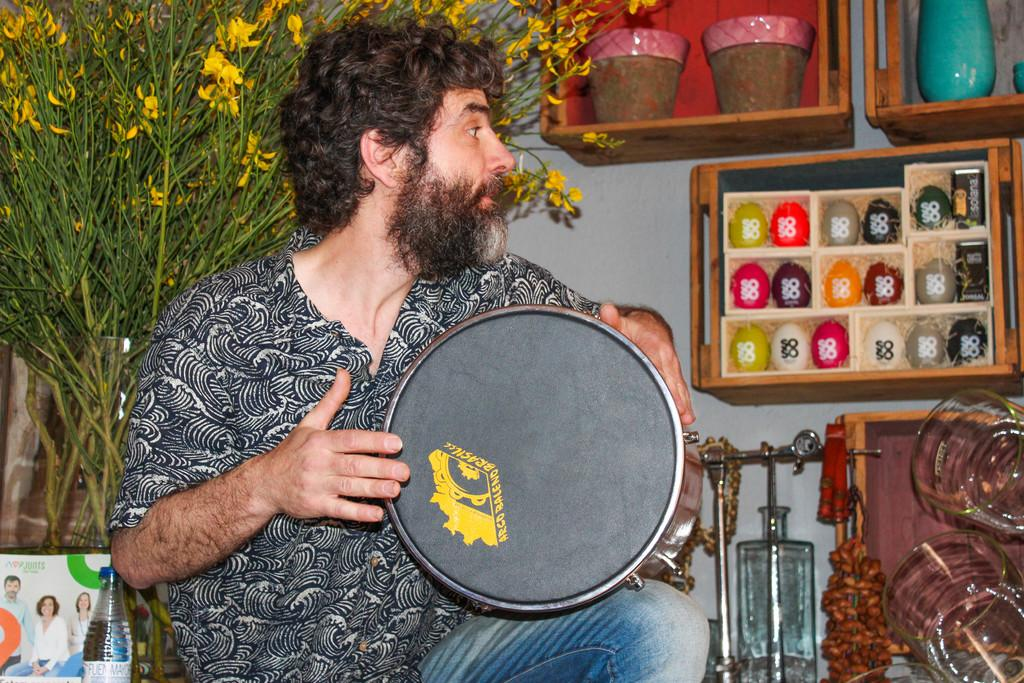What is the person in the image holding? The person is holding a drum. What can be seen in the background of the image? There is a plant and flower pots in the background of the image. Can you see any cables in the image? There are no cables visible in the image. What type of wave is the person riding in the image? There is no wave present in the image; it is a person holding a drum with a plant and flower pots in the background. 